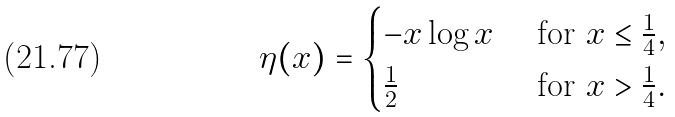<formula> <loc_0><loc_0><loc_500><loc_500>\eta ( x ) = \begin{cases} - x \log x & \text { for } x \leq \frac { 1 } { 4 } , \\ \frac { 1 } { 2 } & \text { for } x > \frac { 1 } { 4 } . \end{cases}</formula> 